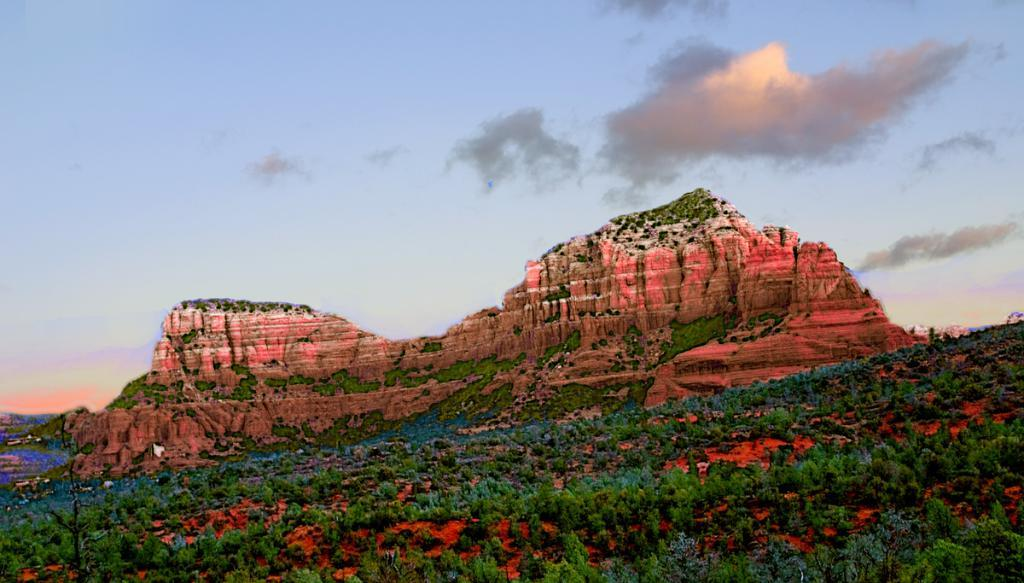What type of vegetation can be seen in the image? There are trees in the image. What natural feature is visible in the background of the image? There are mountains visible in the background of the image. What part of the natural environment is visible in the image? The sky is visible in the image. What is present in the sky? Clouds are present in the sky. What type of rice can be seen growing on the sofa in the image? There is no rice or sofa present in the image; it features trees, mountains, sky, and clouds. What kind of paste is being used to create the clouds in the image? There is no paste used to create the clouds in the image; clouds are a natural atmospheric phenomenon. 